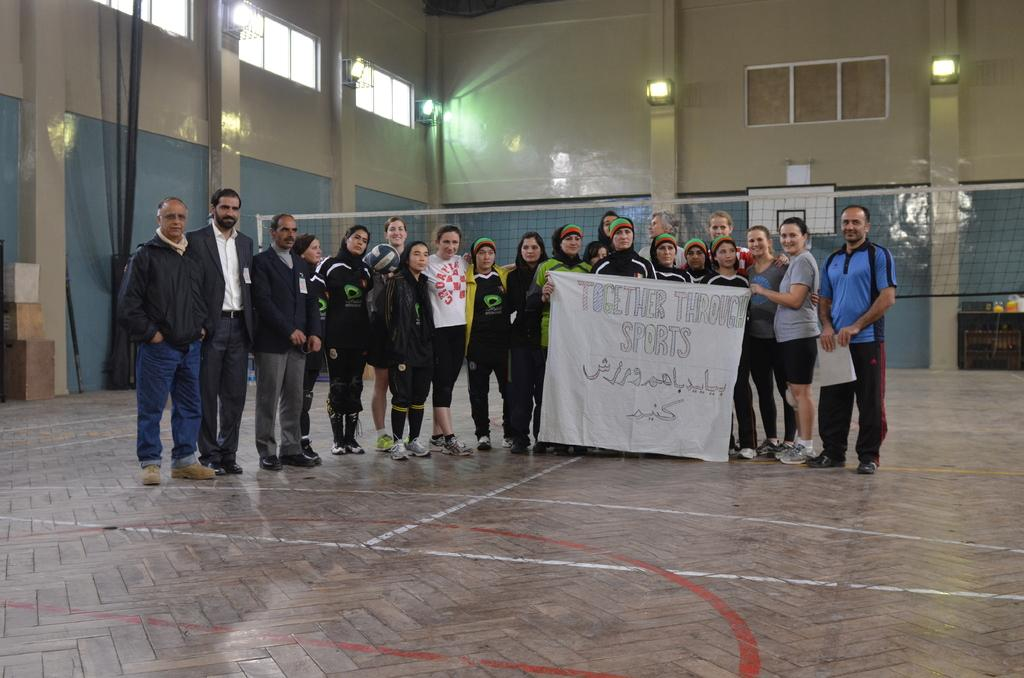How many people are in the image? There is a group of people in the image, but the exact number cannot be determined from the provided facts. What are the people in the image doing? The people are posing for a camera in the image. What do the people have in their hands? The people are holding a banner in the image. What can be seen in the background of the image? There are lights, a mesh, windows, and a wall in the background of the image. What type of comb is being used by the people in the image? There is no comb present in the image; the people are holding a banner. How many spiders are visible on the wall in the image? There is no mention of spiders in the image; the wall is part of the background, but no specific details about it are provided. 